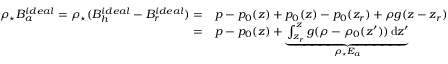Convert formula to latex. <formula><loc_0><loc_0><loc_500><loc_500>\begin{array} { r l } { \rho _ { ^ { * } } B _ { a } ^ { i d e a l } = \rho _ { ^ { * } } ( B _ { h } ^ { i d e a l } - B _ { r } ^ { i d e a l } ) = } & { p - p _ { 0 } ( z ) + p _ { 0 } ( z ) - p _ { 0 } ( z _ { r } ) + \rho g ( z - z _ { r } ) } \\ { = } & { p - p _ { 0 } ( z ) + \underbrace { \int _ { z _ { r } } ^ { z } g ( \rho - \rho _ { 0 } ( z ^ { \prime } ) ) \, d z ^ { \prime } } _ { \rho _ { ^ { * } } E _ { a } } } \end{array}</formula> 